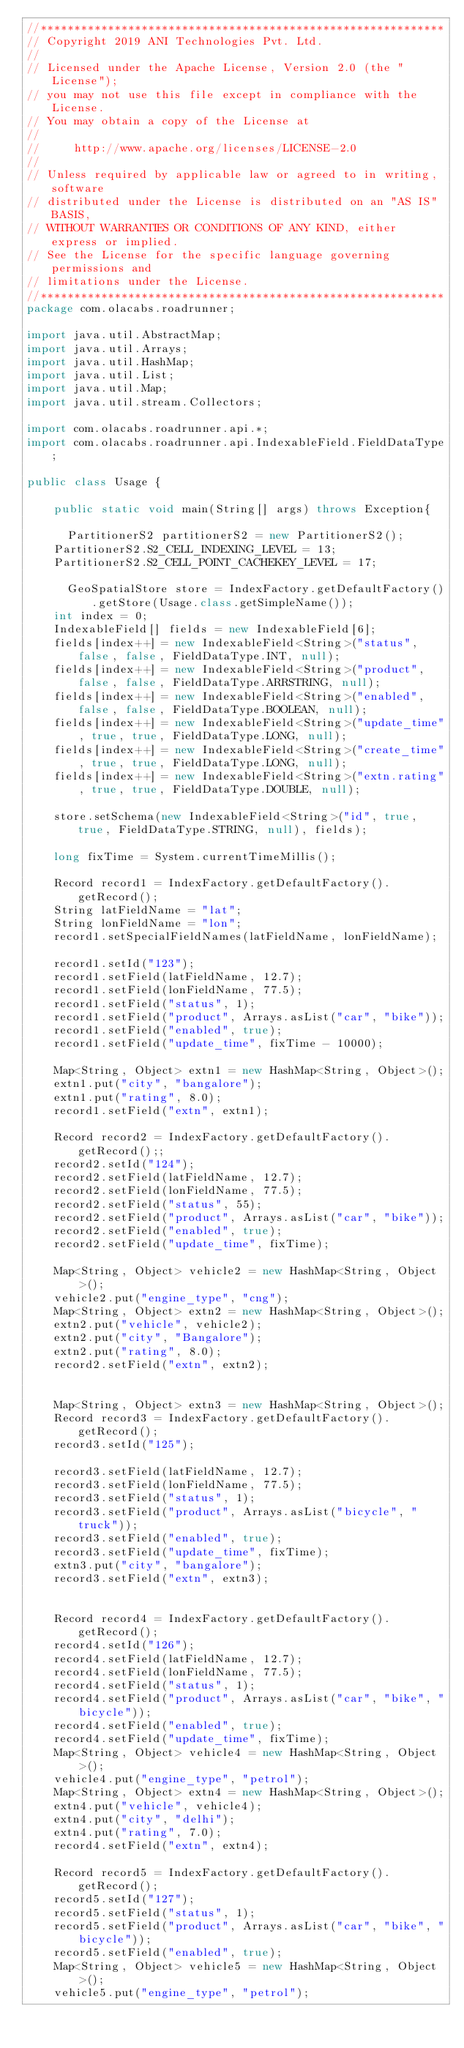<code> <loc_0><loc_0><loc_500><loc_500><_Java_>//************************************************************
// Copyright 2019 ANI Technologies Pvt. Ltd.
//
// Licensed under the Apache License, Version 2.0 (the "License");
// you may not use this file except in compliance with the License.
// You may obtain a copy of the License at
//
//     http://www.apache.org/licenses/LICENSE-2.0
//
// Unless required by applicable law or agreed to in writing, software
// distributed under the License is distributed on an "AS IS" BASIS,
// WITHOUT WARRANTIES OR CONDITIONS OF ANY KIND, either express or implied.
// See the License for the specific language governing permissions and
// limitations under the License.
//************************************************************
package com.olacabs.roadrunner;

import java.util.AbstractMap;
import java.util.Arrays;
import java.util.HashMap;
import java.util.List;
import java.util.Map;
import java.util.stream.Collectors;

import com.olacabs.roadrunner.api.*;
import com.olacabs.roadrunner.api.IndexableField.FieldDataType;

public class Usage {

    public static void main(String[] args) throws Exception{

    	PartitionerS2 partitionerS2 = new PartitionerS2();
		PartitionerS2.S2_CELL_INDEXING_LEVEL = 13;
	 	PartitionerS2.S2_CELL_POINT_CACHEKEY_LEVEL = 17;
	 	
    	GeoSpatialStore store = IndexFactory.getDefaultFactory().getStore(Usage.class.getSimpleName());
		int index = 0;
		IndexableField[] fields = new IndexableField[6];
		fields[index++] = new IndexableField<String>("status", false, false, FieldDataType.INT, null);
		fields[index++] = new IndexableField<String>("product", false, false, FieldDataType.ARRSTRING, null);
		fields[index++] = new IndexableField<String>("enabled", false, false, FieldDataType.BOOLEAN, null);
		fields[index++] = new IndexableField<String>("update_time", true, true, FieldDataType.LONG, null);
		fields[index++] = new IndexableField<String>("create_time", true, true, FieldDataType.LONG, null);
		fields[index++] = new IndexableField<String>("extn.rating", true, true, FieldDataType.DOUBLE, null);

		store.setSchema(new IndexableField<String>("id", true, true, FieldDataType.STRING, null), fields);
		
		long fixTime = System.currentTimeMillis();

		Record record1 = IndexFactory.getDefaultFactory().getRecord();
		String latFieldName = "lat";
		String lonFieldName = "lon";
		record1.setSpecialFieldNames(latFieldName, lonFieldName);

		record1.setId("123");
		record1.setField(latFieldName, 12.7);
		record1.setField(lonFieldName, 77.5);
		record1.setField("status", 1);
		record1.setField("product", Arrays.asList("car", "bike"));
		record1.setField("enabled", true);
		record1.setField("update_time", fixTime - 10000);

		Map<String, Object> extn1 = new HashMap<String, Object>();
		extn1.put("city", "bangalore");
		extn1.put("rating", 8.0);
		record1.setField("extn", extn1);

		Record record2 = IndexFactory.getDefaultFactory().getRecord();;
		record2.setId("124");
		record2.setField(latFieldName, 12.7);
		record2.setField(lonFieldName, 77.5);
		record2.setField("status", 55);
		record2.setField("product", Arrays.asList("car", "bike"));
		record2.setField("enabled", true);
		record2.setField("update_time", fixTime);

		Map<String, Object> vehicle2 = new HashMap<String, Object>();
		vehicle2.put("engine_type", "cng");
		Map<String, Object> extn2 = new HashMap<String, Object>();
		extn2.put("vehicle", vehicle2);
		extn2.put("city", "Bangalore");
		extn2.put("rating", 8.0);
		record2.setField("extn", extn2);

		
		Map<String, Object> extn3 = new HashMap<String, Object>();
		Record record3 = IndexFactory.getDefaultFactory().getRecord();
		record3.setId("125");

		record3.setField(latFieldName, 12.7);
		record3.setField(lonFieldName, 77.5);
		record3.setField("status", 1);
		record3.setField("product", Arrays.asList("bicycle", "truck"));
		record3.setField("enabled", true);
		record3.setField("update_time", fixTime);
		extn3.put("city", "bangalore");
		record3.setField("extn", extn3);

		
		Record record4 = IndexFactory.getDefaultFactory().getRecord();
		record4.setId("126");
		record4.setField(latFieldName, 12.7);
		record4.setField(lonFieldName, 77.5);
		record4.setField("status", 1);
		record4.setField("product", Arrays.asList("car", "bike", "bicycle"));
		record4.setField("enabled", true);
		record4.setField("update_time", fixTime);
		Map<String, Object> vehicle4 = new HashMap<String, Object>();
		vehicle4.put("engine_type", "petrol");
		Map<String, Object> extn4 = new HashMap<String, Object>();
		extn4.put("vehicle", vehicle4);
		extn4.put("city", "delhi");
		extn4.put("rating", 7.0);
		record4.setField("extn", extn4);
		
		Record record5 = IndexFactory.getDefaultFactory().getRecord();
		record5.setId("127");
		record5.setField("status", 1);
		record5.setField("product", Arrays.asList("car", "bike", "bicycle"));
		record5.setField("enabled", true);
		Map<String, Object> vehicle5 = new HashMap<String, Object>();
		vehicle5.put("engine_type", "petrol");</code> 